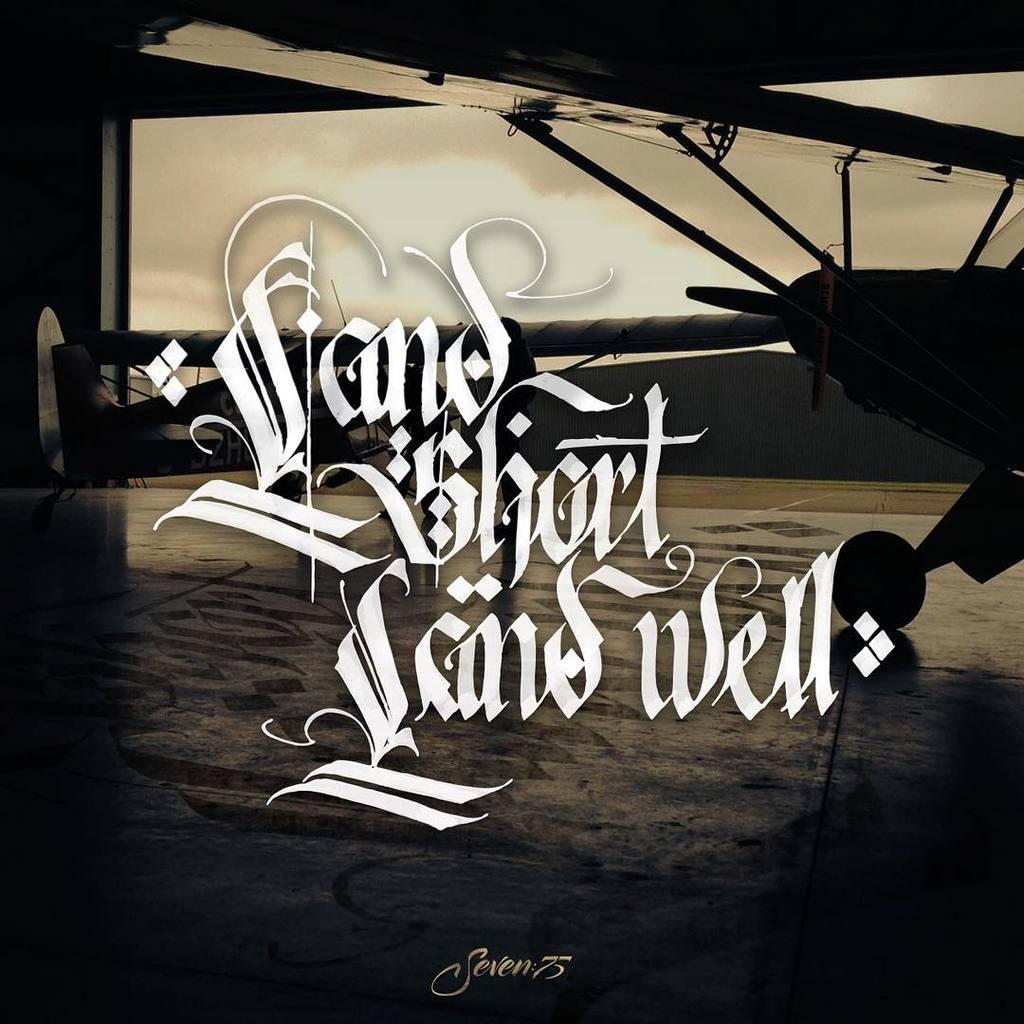In one or two sentences, can you explain what this image depicts? In this picture we can see a plane and white color text. 